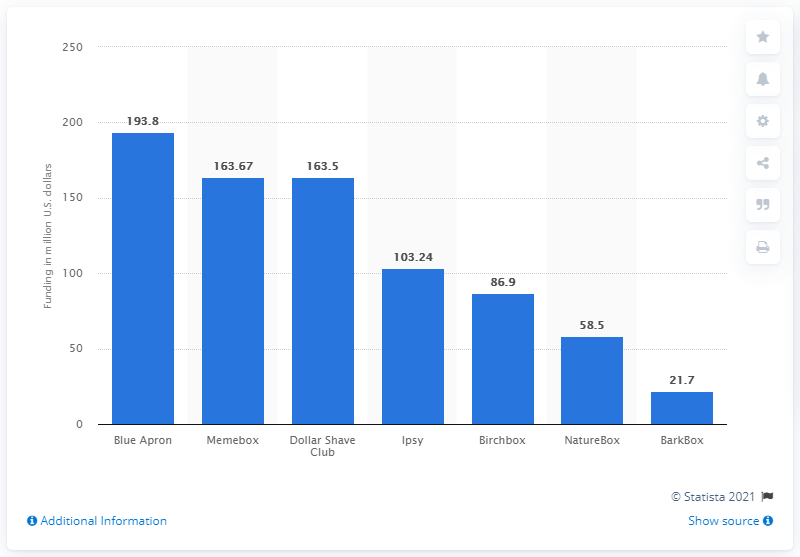Draw attention to some important aspects in this diagram. As of November 2016, Ipsy had raised a total of $103.24 million in funding. Ipsy raised 103.24 million dollars in funding in November 2016, making it one of the most successful beauty box companies in the industry. 